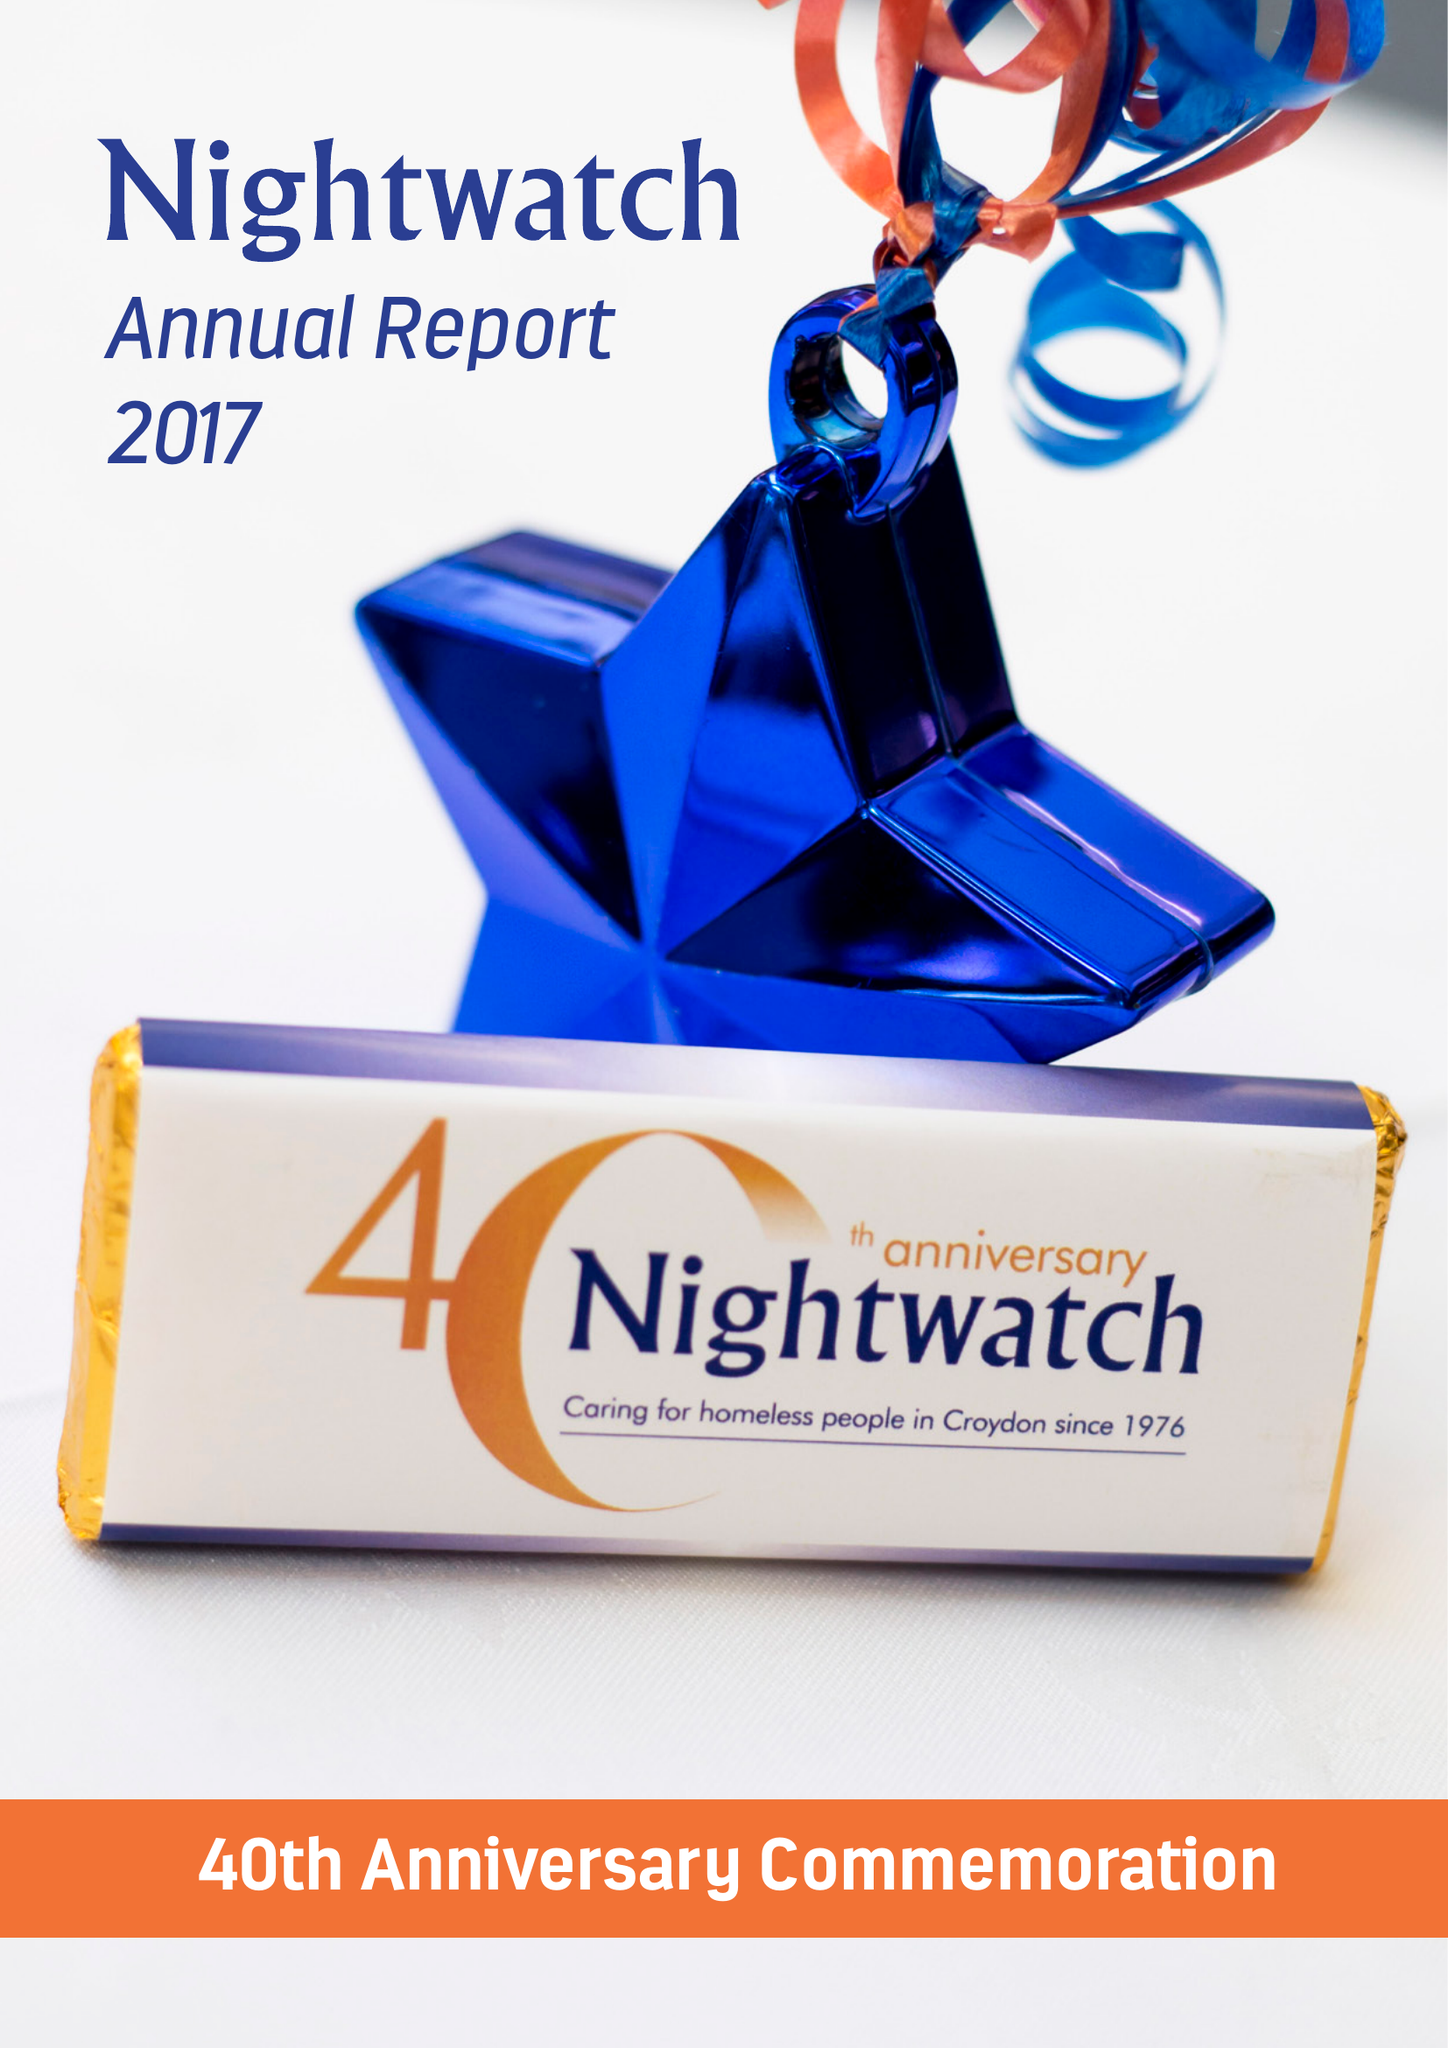What is the value for the address__post_town?
Answer the question using a single word or phrase. LONDON 